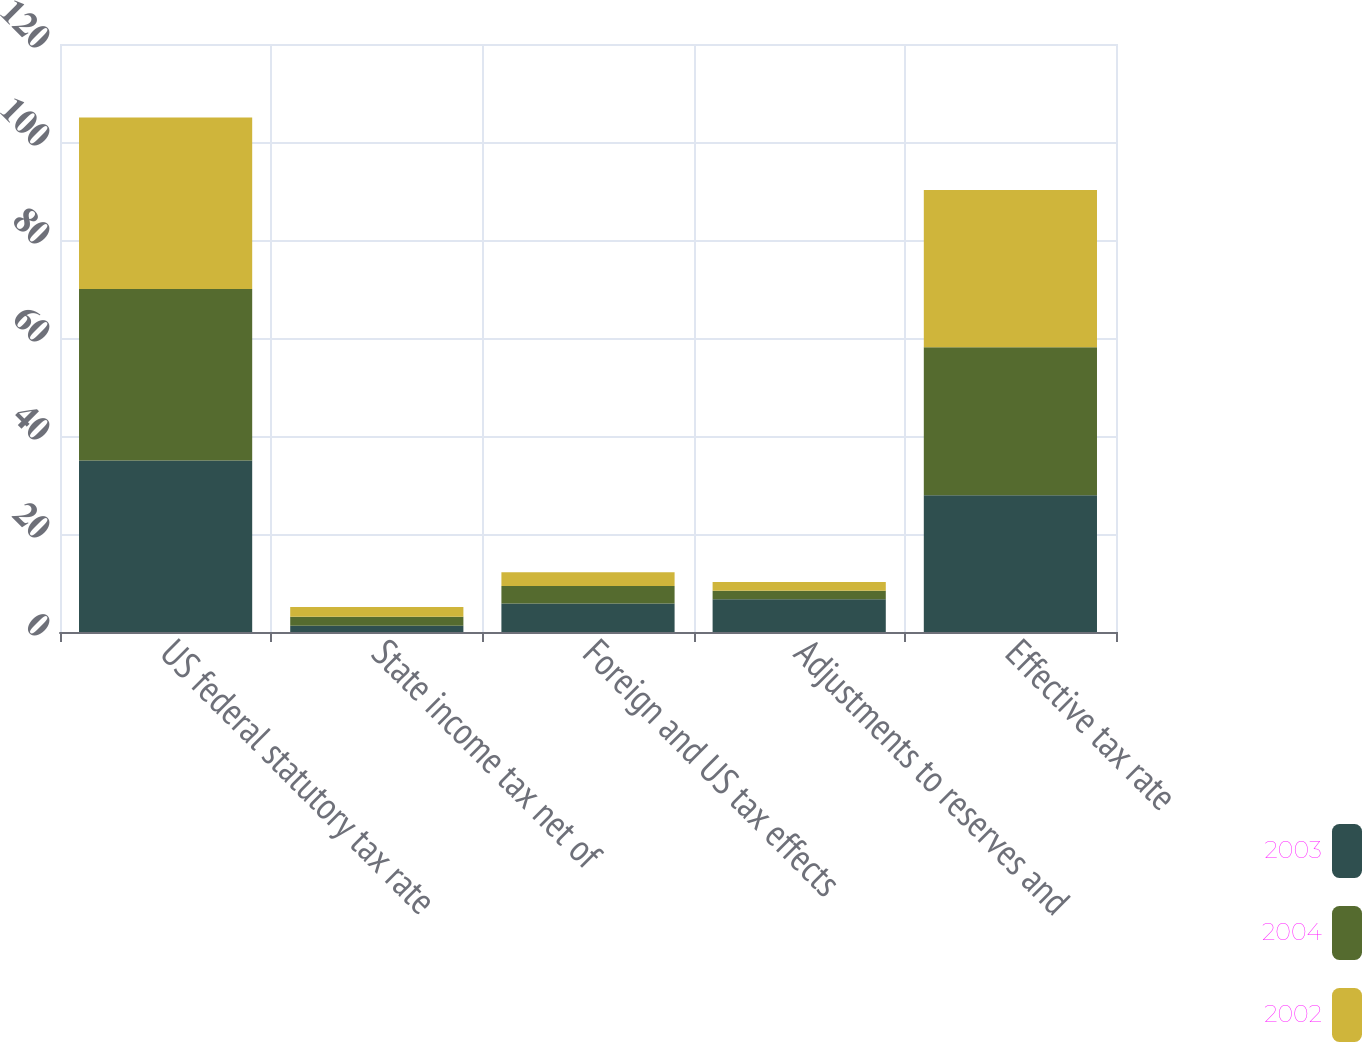<chart> <loc_0><loc_0><loc_500><loc_500><stacked_bar_chart><ecel><fcel>US federal statutory tax rate<fcel>State income tax net of<fcel>Foreign and US tax effects<fcel>Adjustments to reserves and<fcel>Effective tax rate<nl><fcel>2003<fcel>35<fcel>1.3<fcel>5.8<fcel>6.7<fcel>27.9<nl><fcel>2004<fcel>35<fcel>1.8<fcel>3.6<fcel>1.7<fcel>30.2<nl><fcel>2002<fcel>35<fcel>2<fcel>2.8<fcel>1.8<fcel>32.1<nl></chart> 